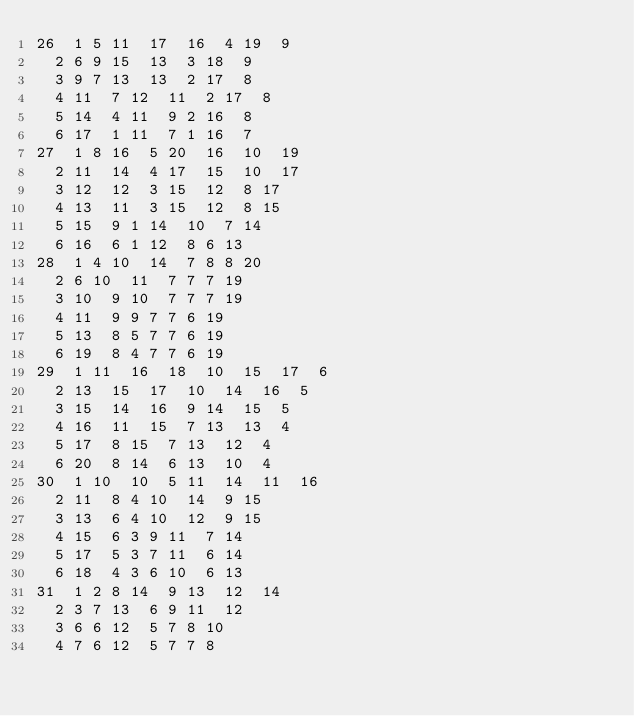Convert code to text. <code><loc_0><loc_0><loc_500><loc_500><_ObjectiveC_>26	1	5	11	17	16	4	19	9	
	2	6	9	15	13	3	18	9	
	3	9	7	13	13	2	17	8	
	4	11	7	12	11	2	17	8	
	5	14	4	11	9	2	16	8	
	6	17	1	11	7	1	16	7	
27	1	8	16	5	20	16	10	19	
	2	11	14	4	17	15	10	17	
	3	12	12	3	15	12	8	17	
	4	13	11	3	15	12	8	15	
	5	15	9	1	14	10	7	14	
	6	16	6	1	12	8	6	13	
28	1	4	10	14	7	8	8	20	
	2	6	10	11	7	7	7	19	
	3	10	9	10	7	7	7	19	
	4	11	9	9	7	7	6	19	
	5	13	8	5	7	7	6	19	
	6	19	8	4	7	7	6	19	
29	1	11	16	18	10	15	17	6	
	2	13	15	17	10	14	16	5	
	3	15	14	16	9	14	15	5	
	4	16	11	15	7	13	13	4	
	5	17	8	15	7	13	12	4	
	6	20	8	14	6	13	10	4	
30	1	10	10	5	11	14	11	16	
	2	11	8	4	10	14	9	15	
	3	13	6	4	10	12	9	15	
	4	15	6	3	9	11	7	14	
	5	17	5	3	7	11	6	14	
	6	18	4	3	6	10	6	13	
31	1	2	8	14	9	13	12	14	
	2	3	7	13	6	9	11	12	
	3	6	6	12	5	7	8	10	
	4	7	6	12	5	7	7	8	</code> 